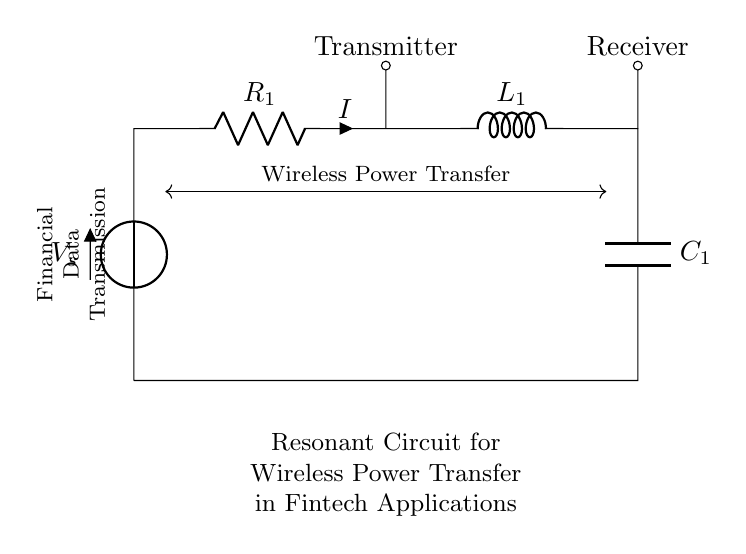What is the function of C1 in this circuit? C1 is a capacitor that stores energy in an electric field, which is crucial for resonance in the circuit and helps in energy transfer.
Answer: capacitor What are the components of this circuit? The components include a voltage source (V), a resistor (R1), an inductor (L1), and a capacitor (C1).
Answer: voltage source, resistor, inductor, capacitor Which component is used for wireless power transfer? The combination of the inductor L1 and capacitor C1 forms a resonant circuit, allowing efficient wireless power transfer.
Answer: inductor and capacitor What is the role of R1 in the circuit? R1 limits the current in the circuit and may also affect the quality factor (Q factor) of the resonant circuit, which is important for tuning.
Answer: current limiter What can be inferred about the connections between components? The components are connected in series, creating a path for current to flow, which facilitates energy transfer and resonance.
Answer: series connection What does the diagram indicate about data transmission? The diagram suggests that the circuit may also facilitate the transmission of financial data alongside power transfer, indicated by the labeling.
Answer: data transmission 